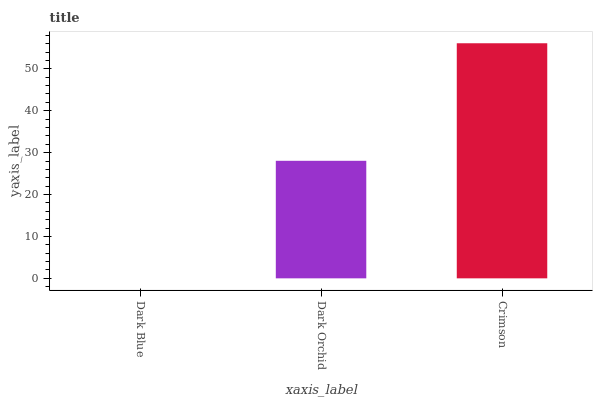Is Dark Blue the minimum?
Answer yes or no. Yes. Is Crimson the maximum?
Answer yes or no. Yes. Is Dark Orchid the minimum?
Answer yes or no. No. Is Dark Orchid the maximum?
Answer yes or no. No. Is Dark Orchid greater than Dark Blue?
Answer yes or no. Yes. Is Dark Blue less than Dark Orchid?
Answer yes or no. Yes. Is Dark Blue greater than Dark Orchid?
Answer yes or no. No. Is Dark Orchid less than Dark Blue?
Answer yes or no. No. Is Dark Orchid the high median?
Answer yes or no. Yes. Is Dark Orchid the low median?
Answer yes or no. Yes. Is Dark Blue the high median?
Answer yes or no. No. Is Dark Blue the low median?
Answer yes or no. No. 